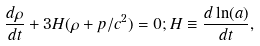Convert formula to latex. <formula><loc_0><loc_0><loc_500><loc_500>\frac { d \rho } { d t } + 3 H ( \rho + p / c ^ { 2 } ) = 0 ; H \equiv \frac { d \ln ( a ) } { d t } ,</formula> 